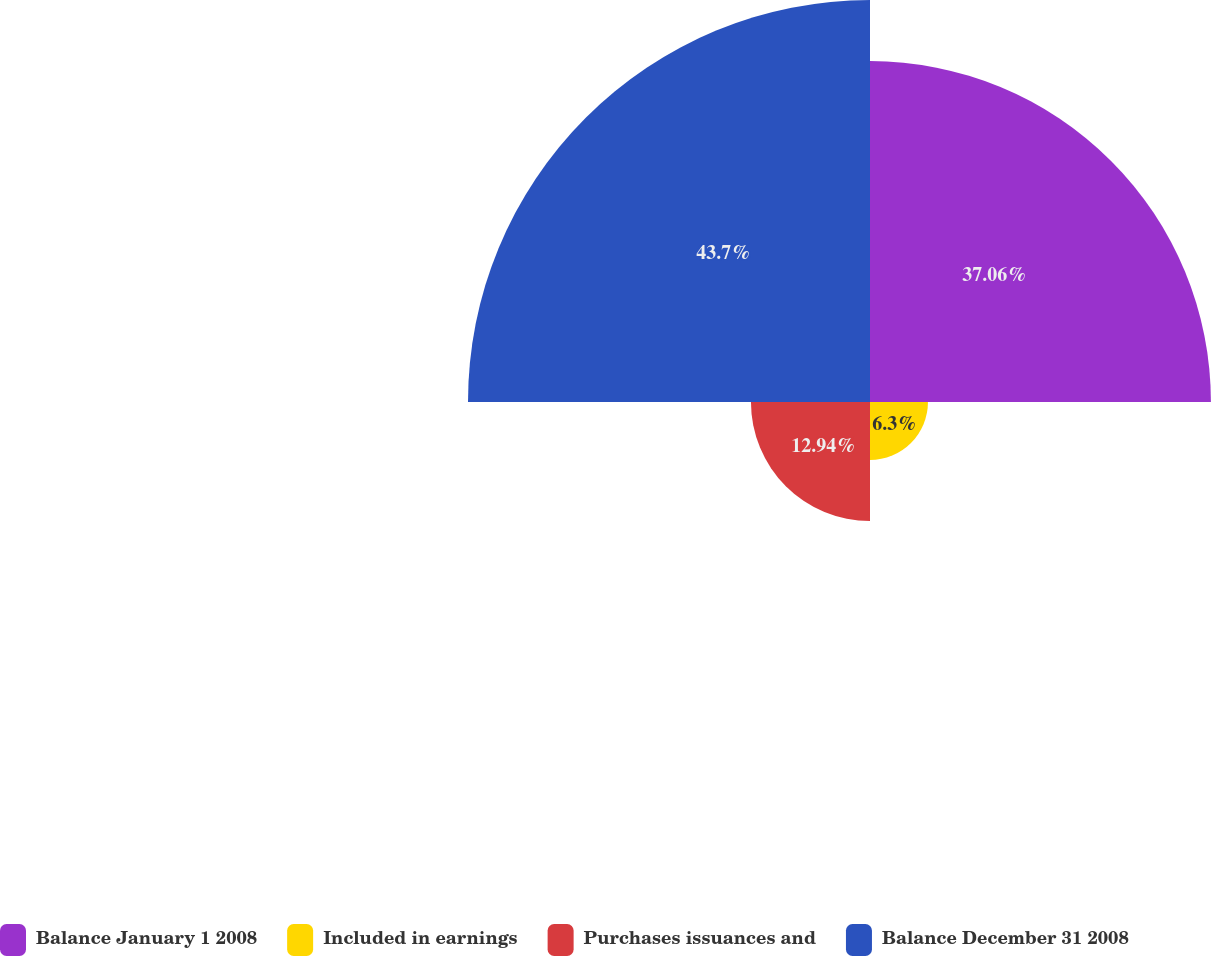<chart> <loc_0><loc_0><loc_500><loc_500><pie_chart><fcel>Balance January 1 2008<fcel>Included in earnings<fcel>Purchases issuances and<fcel>Balance December 31 2008<nl><fcel>37.06%<fcel>6.3%<fcel>12.94%<fcel>43.7%<nl></chart> 